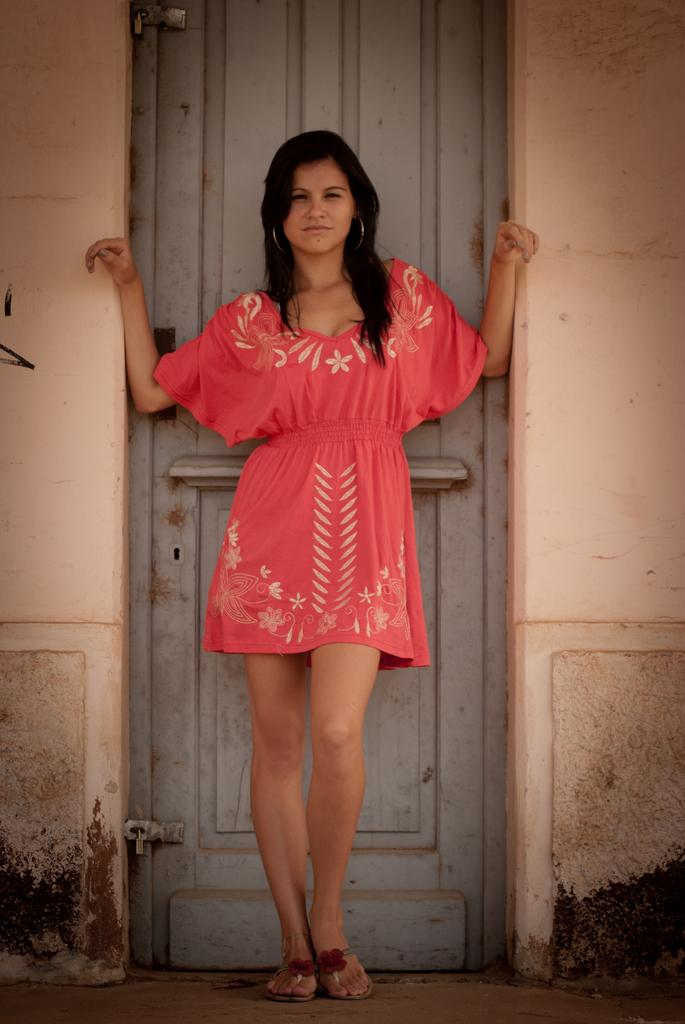Who is present in the image? There is a woman in the image. Where is the woman located in relation to the door? The woman is standing near a door. What other architectural features are near the woman? The woman is standing near walls. What is the woman doing in the image? The woman is looking at something. What type of surface is visible beneath the woman? There is a floor visible in the image. What type of rifle is the woman holding in the image? There is no rifle present in the image; the woman is simply standing near a door and walls. 